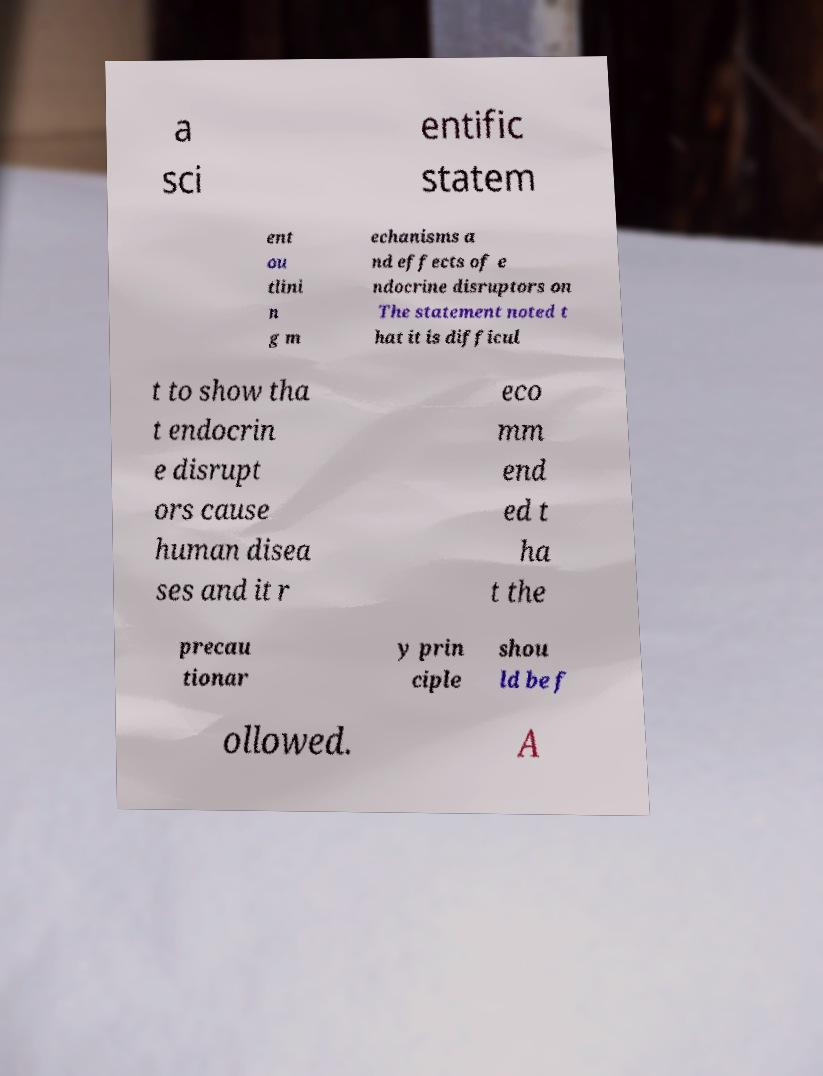Please read and relay the text visible in this image. What does it say? a sci entific statem ent ou tlini n g m echanisms a nd effects of e ndocrine disruptors on The statement noted t hat it is difficul t to show tha t endocrin e disrupt ors cause human disea ses and it r eco mm end ed t ha t the precau tionar y prin ciple shou ld be f ollowed. A 